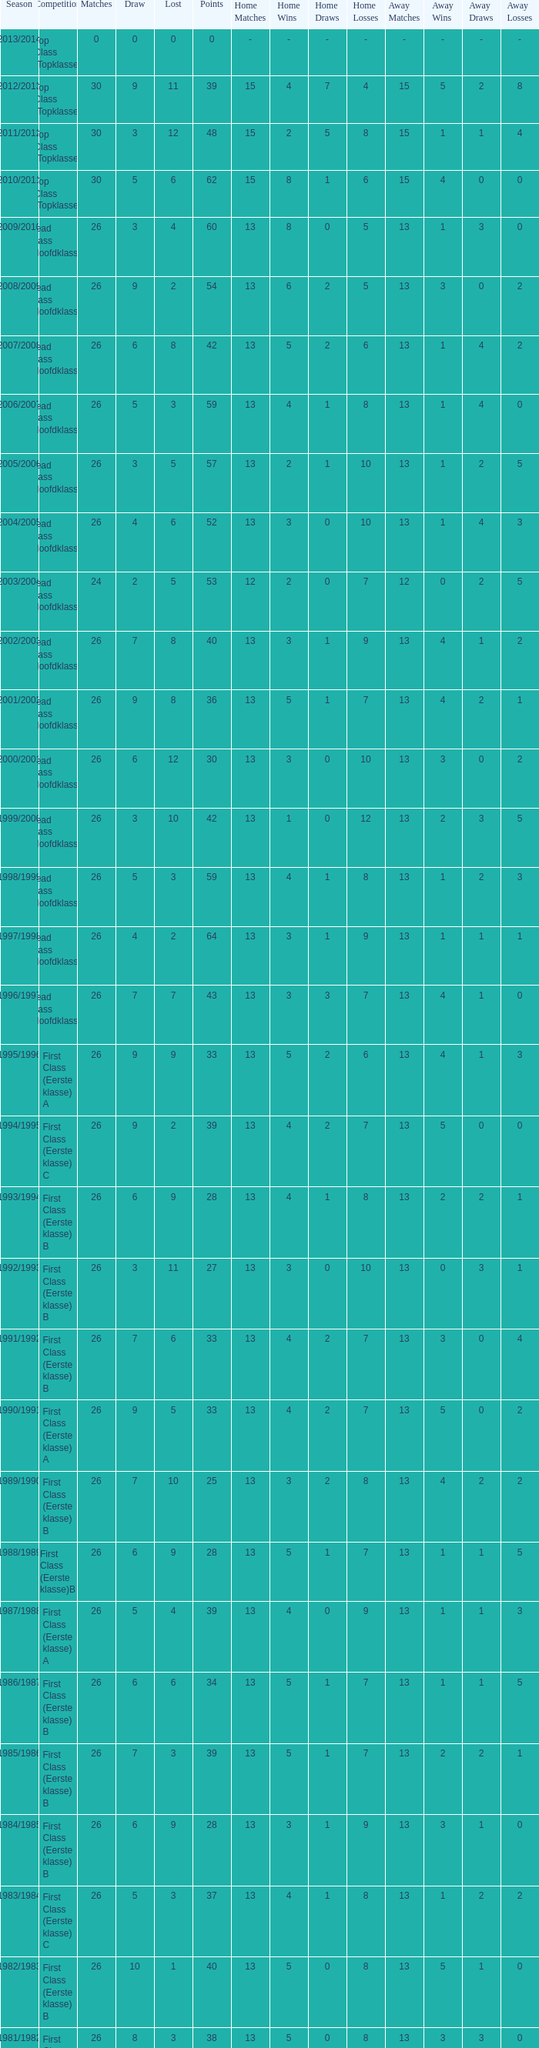What competition has a score greater than 30, a draw less than 5, and a loss larger than 10? Top Class (Topklasse). 